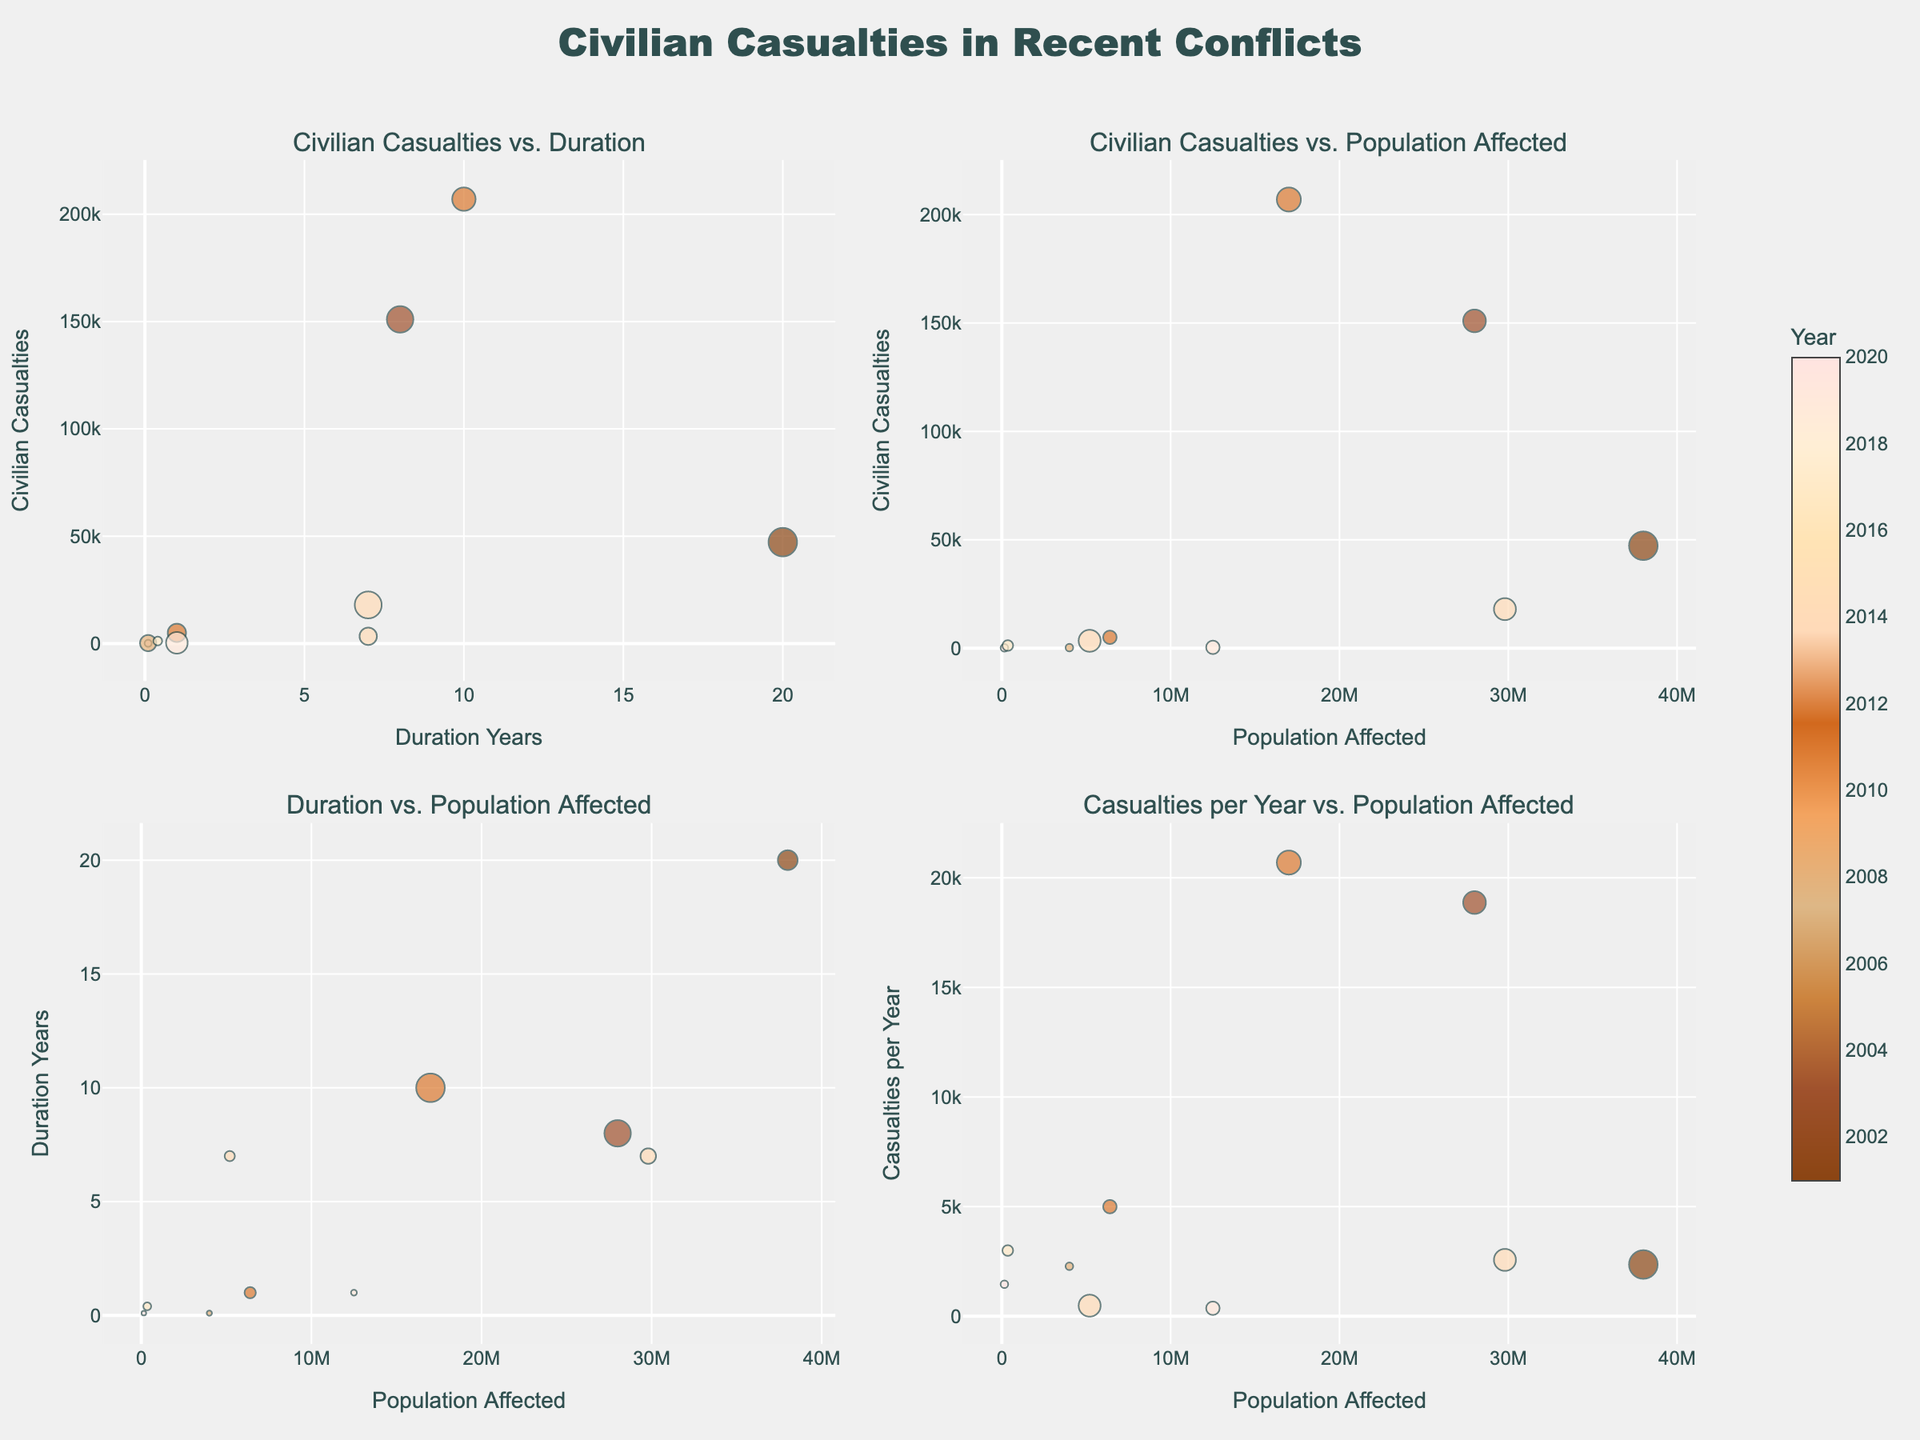What is the subplot title for the graph comparing 'Civilian Casualties' and 'Duration'? The subplot title is located above the respective graph in the figure. For the graph comparing 'Civilian Casualties' and 'Duration', the title is "Civilian Casualties vs. Duration".
Answer: Civilian Casualties vs. Duration How many conflicts are depicted in the subplot titled 'Civilian Casualties vs. Population Affected'? Each bubble in the subplot represents one conflict. By counting the bubbles, we can determine the number of conflicts. There are 10 conflicts in total depicted in that subplot.
Answer: 10 Which conflict has the highest casualties per year? To find this, look at the subplot titled "Casualties per Year vs. Population Affected". Identify the highest point on the y-axis, which represents the maximum casualties per year. The conflict with this point is the Russo-Georgian War.
Answer: Russo-Georgian War Compare civilian casualties in the Syrian Civil War and the War in Afghanistan. Which conflict resulted in more casualties? Locate the Syrian Civil War and War in Afghanistan in any subplot that includes 'Civilian Casualties'. Observe their positions on the y-axis where 'Civilian Casualties' is plotted. The Syrian Civil War shows more civilian casualties at 207,000 compared to the War in Afghanistan with 47,245.
Answer: Syrian Civil War In which subplot can we see the relationship between the size of the population affected and the duration of conflicts? The subplot titles indicate the variables compared. The fourth subplot title is "Duration vs. Population Affected", which visualizes this relationship.
Answer: Duration vs. Population Affected What is the duration of the Yemeni Civil War? Locate the Yemeni Civil War bubble in any subplot containing 'Duration_Years'. The marker size can also help identify it. The duration of the Yemeni Civil War is shown on the x-axis (7 years).
Answer: 7 years Which conflict had the smallest population affected, and what is the size of that population? Look at the subplot with 'Population Affected' on the x-axis and identify the smallest marker size, corresponding to the smallest population affected. The smallest population affected is seen in the Nagorno-Karabakh War, with a population of 150,000.
Answer: Nagorno-Karabakh War, 150,000 Are there any conflicts that lasted less than 1 year? Which ones? Look at subplots including 'Duration_Years' on the x-axis. Identify any bubbles to the left of the 1-year mark. The Russian-Georgian War and Nagorno-Karabakh War both lasted less than 1 year (0.1 year for each).
Answer: Russo-Georgian War, Nagorno-Karabakh War Which conflict incurred more civilian casualties: the Marawi Siege or the War in Donbass? Compare the positions of the bubbles for the Marawi Siege and the War in Donbass in subplots with 'Civilian Casualties' on the y-axis. The War in Donbass has 3,393 casualties, while the Marawi Siege has 1,200.
Answer: War in Donbass Which conflict affected a larger population, the Libyan Civil War or the Kashmir Conflict? In any subplot displaying 'Population Affected', compare the size of the markers or their positions on the x-axis for the Libyan Civil War and Kashmir Conflict. The Kashmir Conflict affected a larger population (12,500,000 compared to 6,400,000).
Answer: Kashmir Conflict 